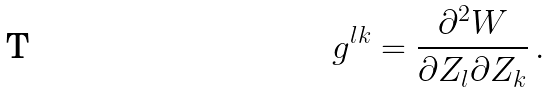<formula> <loc_0><loc_0><loc_500><loc_500>g ^ { l k } = \frac { \partial ^ { 2 } W } { \partial Z _ { l } \partial Z _ { k } } \, .</formula> 